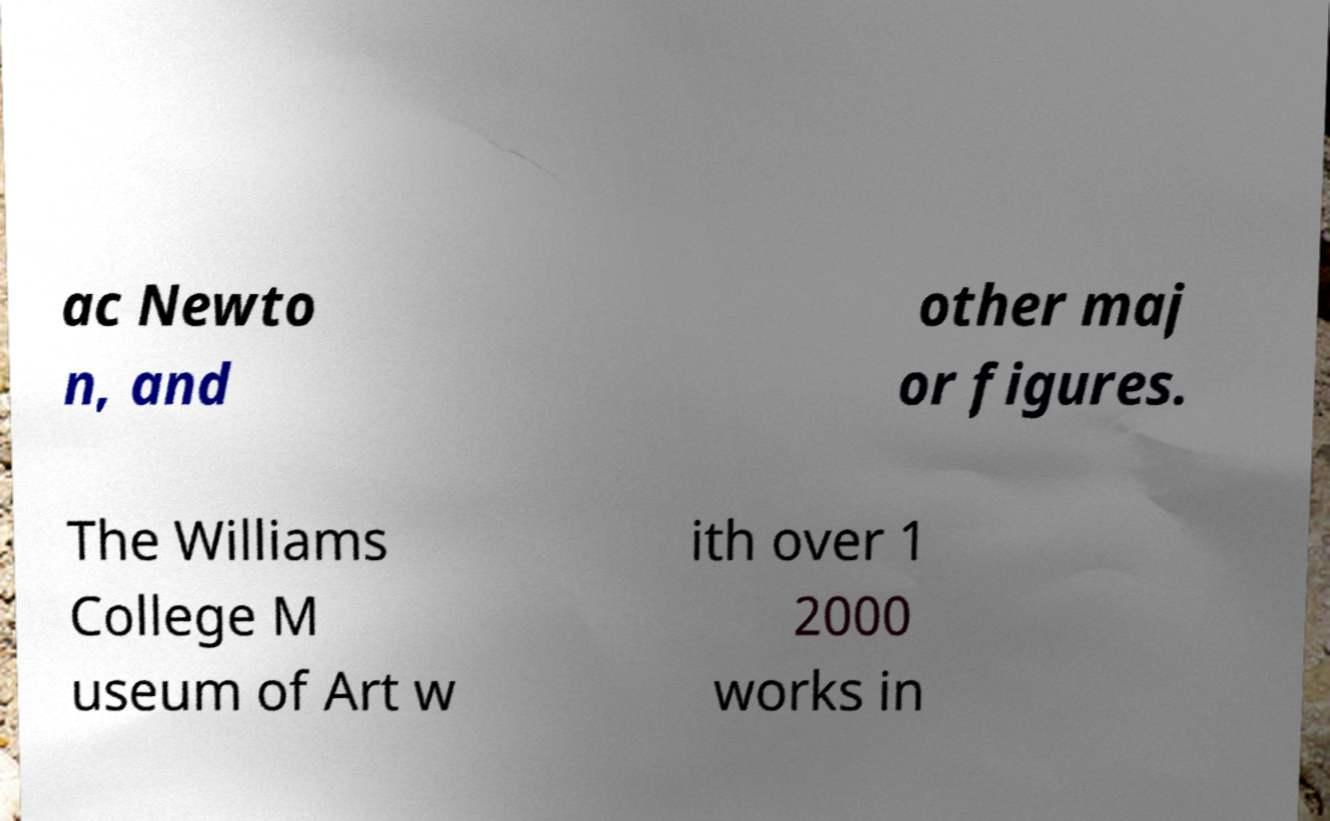I need the written content from this picture converted into text. Can you do that? ac Newto n, and other maj or figures. The Williams College M useum of Art w ith over 1 2000 works in 